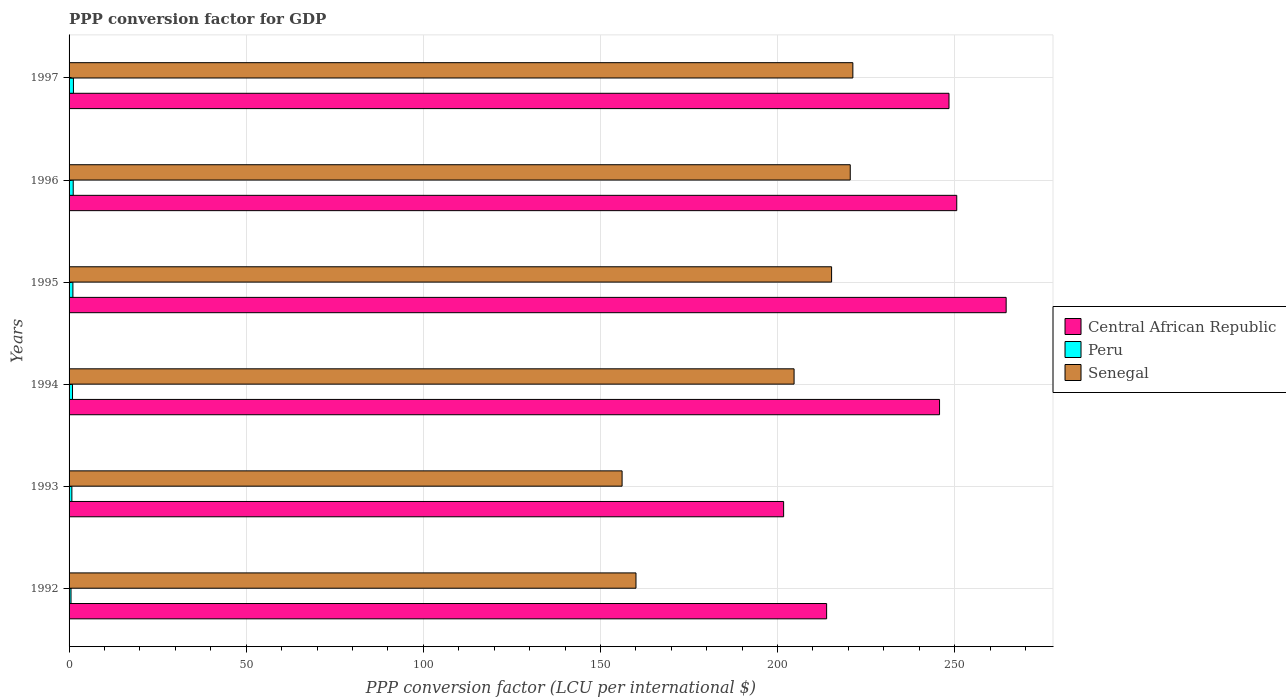How many groups of bars are there?
Provide a short and direct response. 6. How many bars are there on the 3rd tick from the top?
Provide a succinct answer. 3. How many bars are there on the 5th tick from the bottom?
Offer a terse response. 3. What is the PPP conversion factor for GDP in Peru in 1993?
Provide a succinct answer. 0.79. Across all years, what is the maximum PPP conversion factor for GDP in Peru?
Offer a very short reply. 1.23. Across all years, what is the minimum PPP conversion factor for GDP in Central African Republic?
Your answer should be compact. 201.72. In which year was the PPP conversion factor for GDP in Senegal minimum?
Offer a terse response. 1993. What is the total PPP conversion factor for GDP in Senegal in the graph?
Keep it short and to the point. 1177.87. What is the difference between the PPP conversion factor for GDP in Peru in 1996 and that in 1997?
Your answer should be very brief. -0.06. What is the difference between the PPP conversion factor for GDP in Peru in 1993 and the PPP conversion factor for GDP in Senegal in 1997?
Offer a terse response. -220.47. What is the average PPP conversion factor for GDP in Senegal per year?
Give a very brief answer. 196.31. In the year 1996, what is the difference between the PPP conversion factor for GDP in Senegal and PPP conversion factor for GDP in Central African Republic?
Your answer should be compact. -30.06. What is the ratio of the PPP conversion factor for GDP in Central African Republic in 1995 to that in 1996?
Provide a succinct answer. 1.06. Is the PPP conversion factor for GDP in Peru in 1994 less than that in 1995?
Give a very brief answer. Yes. What is the difference between the highest and the second highest PPP conversion factor for GDP in Senegal?
Offer a very short reply. 0.74. What is the difference between the highest and the lowest PPP conversion factor for GDP in Central African Republic?
Offer a very short reply. 62.82. In how many years, is the PPP conversion factor for GDP in Central African Republic greater than the average PPP conversion factor for GDP in Central African Republic taken over all years?
Ensure brevity in your answer.  4. What does the 3rd bar from the top in 1994 represents?
Your answer should be compact. Central African Republic. What does the 3rd bar from the bottom in 1993 represents?
Make the answer very short. Senegal. How many bars are there?
Keep it short and to the point. 18. What is the difference between two consecutive major ticks on the X-axis?
Your response must be concise. 50. Does the graph contain grids?
Provide a succinct answer. Yes. Where does the legend appear in the graph?
Provide a succinct answer. Center right. How many legend labels are there?
Your answer should be compact. 3. How are the legend labels stacked?
Provide a succinct answer. Vertical. What is the title of the graph?
Offer a very short reply. PPP conversion factor for GDP. What is the label or title of the X-axis?
Make the answer very short. PPP conversion factor (LCU per international $). What is the label or title of the Y-axis?
Your answer should be compact. Years. What is the PPP conversion factor (LCU per international $) in Central African Republic in 1992?
Offer a terse response. 213.86. What is the PPP conversion factor (LCU per international $) of Peru in 1992?
Ensure brevity in your answer.  0.55. What is the PPP conversion factor (LCU per international $) of Senegal in 1992?
Make the answer very short. 160.04. What is the PPP conversion factor (LCU per international $) in Central African Republic in 1993?
Your answer should be compact. 201.72. What is the PPP conversion factor (LCU per international $) of Peru in 1993?
Give a very brief answer. 0.79. What is the PPP conversion factor (LCU per international $) in Senegal in 1993?
Your response must be concise. 156.12. What is the PPP conversion factor (LCU per international $) of Central African Republic in 1994?
Offer a terse response. 245.73. What is the PPP conversion factor (LCU per international $) of Peru in 1994?
Your answer should be very brief. 0.97. What is the PPP conversion factor (LCU per international $) in Senegal in 1994?
Offer a terse response. 204.67. What is the PPP conversion factor (LCU per international $) in Central African Republic in 1995?
Provide a succinct answer. 264.54. What is the PPP conversion factor (LCU per international $) of Peru in 1995?
Your response must be concise. 1.08. What is the PPP conversion factor (LCU per international $) in Senegal in 1995?
Your answer should be very brief. 215.26. What is the PPP conversion factor (LCU per international $) of Central African Republic in 1996?
Offer a terse response. 250.59. What is the PPP conversion factor (LCU per international $) of Peru in 1996?
Make the answer very short. 1.17. What is the PPP conversion factor (LCU per international $) in Senegal in 1996?
Offer a terse response. 220.53. What is the PPP conversion factor (LCU per international $) of Central African Republic in 1997?
Your response must be concise. 248.4. What is the PPP conversion factor (LCU per international $) in Peru in 1997?
Give a very brief answer. 1.23. What is the PPP conversion factor (LCU per international $) of Senegal in 1997?
Make the answer very short. 221.26. Across all years, what is the maximum PPP conversion factor (LCU per international $) in Central African Republic?
Provide a short and direct response. 264.54. Across all years, what is the maximum PPP conversion factor (LCU per international $) in Peru?
Give a very brief answer. 1.23. Across all years, what is the maximum PPP conversion factor (LCU per international $) of Senegal?
Give a very brief answer. 221.26. Across all years, what is the minimum PPP conversion factor (LCU per international $) of Central African Republic?
Offer a very short reply. 201.72. Across all years, what is the minimum PPP conversion factor (LCU per international $) of Peru?
Ensure brevity in your answer.  0.55. Across all years, what is the minimum PPP conversion factor (LCU per international $) of Senegal?
Your response must be concise. 156.12. What is the total PPP conversion factor (LCU per international $) of Central African Republic in the graph?
Ensure brevity in your answer.  1424.84. What is the total PPP conversion factor (LCU per international $) in Peru in the graph?
Make the answer very short. 5.8. What is the total PPP conversion factor (LCU per international $) of Senegal in the graph?
Provide a short and direct response. 1177.87. What is the difference between the PPP conversion factor (LCU per international $) of Central African Republic in 1992 and that in 1993?
Offer a very short reply. 12.14. What is the difference between the PPP conversion factor (LCU per international $) in Peru in 1992 and that in 1993?
Give a very brief answer. -0.24. What is the difference between the PPP conversion factor (LCU per international $) of Senegal in 1992 and that in 1993?
Your answer should be very brief. 3.92. What is the difference between the PPP conversion factor (LCU per international $) in Central African Republic in 1992 and that in 1994?
Offer a terse response. -31.87. What is the difference between the PPP conversion factor (LCU per international $) in Peru in 1992 and that in 1994?
Offer a very short reply. -0.42. What is the difference between the PPP conversion factor (LCU per international $) in Senegal in 1992 and that in 1994?
Keep it short and to the point. -44.63. What is the difference between the PPP conversion factor (LCU per international $) of Central African Republic in 1992 and that in 1995?
Provide a short and direct response. -50.68. What is the difference between the PPP conversion factor (LCU per international $) of Peru in 1992 and that in 1995?
Make the answer very short. -0.53. What is the difference between the PPP conversion factor (LCU per international $) in Senegal in 1992 and that in 1995?
Give a very brief answer. -55.22. What is the difference between the PPP conversion factor (LCU per international $) of Central African Republic in 1992 and that in 1996?
Keep it short and to the point. -36.73. What is the difference between the PPP conversion factor (LCU per international $) in Peru in 1992 and that in 1996?
Your answer should be very brief. -0.62. What is the difference between the PPP conversion factor (LCU per international $) of Senegal in 1992 and that in 1996?
Provide a short and direct response. -60.49. What is the difference between the PPP conversion factor (LCU per international $) of Central African Republic in 1992 and that in 1997?
Offer a terse response. -34.54. What is the difference between the PPP conversion factor (LCU per international $) of Peru in 1992 and that in 1997?
Your answer should be very brief. -0.68. What is the difference between the PPP conversion factor (LCU per international $) of Senegal in 1992 and that in 1997?
Your answer should be compact. -61.22. What is the difference between the PPP conversion factor (LCU per international $) of Central African Republic in 1993 and that in 1994?
Give a very brief answer. -44.01. What is the difference between the PPP conversion factor (LCU per international $) in Peru in 1993 and that in 1994?
Provide a succinct answer. -0.18. What is the difference between the PPP conversion factor (LCU per international $) of Senegal in 1993 and that in 1994?
Keep it short and to the point. -48.55. What is the difference between the PPP conversion factor (LCU per international $) of Central African Republic in 1993 and that in 1995?
Keep it short and to the point. -62.82. What is the difference between the PPP conversion factor (LCU per international $) in Peru in 1993 and that in 1995?
Provide a succinct answer. -0.29. What is the difference between the PPP conversion factor (LCU per international $) of Senegal in 1993 and that in 1995?
Keep it short and to the point. -59.14. What is the difference between the PPP conversion factor (LCU per international $) of Central African Republic in 1993 and that in 1996?
Give a very brief answer. -48.87. What is the difference between the PPP conversion factor (LCU per international $) in Peru in 1993 and that in 1996?
Offer a very short reply. -0.38. What is the difference between the PPP conversion factor (LCU per international $) of Senegal in 1993 and that in 1996?
Keep it short and to the point. -64.41. What is the difference between the PPP conversion factor (LCU per international $) of Central African Republic in 1993 and that in 1997?
Provide a succinct answer. -46.68. What is the difference between the PPP conversion factor (LCU per international $) of Peru in 1993 and that in 1997?
Your answer should be compact. -0.44. What is the difference between the PPP conversion factor (LCU per international $) of Senegal in 1993 and that in 1997?
Offer a terse response. -65.15. What is the difference between the PPP conversion factor (LCU per international $) in Central African Republic in 1994 and that in 1995?
Your answer should be compact. -18.81. What is the difference between the PPP conversion factor (LCU per international $) in Peru in 1994 and that in 1995?
Ensure brevity in your answer.  -0.11. What is the difference between the PPP conversion factor (LCU per international $) of Senegal in 1994 and that in 1995?
Your answer should be compact. -10.59. What is the difference between the PPP conversion factor (LCU per international $) of Central African Republic in 1994 and that in 1996?
Ensure brevity in your answer.  -4.86. What is the difference between the PPP conversion factor (LCU per international $) in Peru in 1994 and that in 1996?
Make the answer very short. -0.2. What is the difference between the PPP conversion factor (LCU per international $) in Senegal in 1994 and that in 1996?
Provide a short and direct response. -15.86. What is the difference between the PPP conversion factor (LCU per international $) in Central African Republic in 1994 and that in 1997?
Give a very brief answer. -2.67. What is the difference between the PPP conversion factor (LCU per international $) in Peru in 1994 and that in 1997?
Keep it short and to the point. -0.26. What is the difference between the PPP conversion factor (LCU per international $) in Senegal in 1994 and that in 1997?
Give a very brief answer. -16.59. What is the difference between the PPP conversion factor (LCU per international $) of Central African Republic in 1995 and that in 1996?
Offer a terse response. 13.95. What is the difference between the PPP conversion factor (LCU per international $) of Peru in 1995 and that in 1996?
Your answer should be compact. -0.09. What is the difference between the PPP conversion factor (LCU per international $) in Senegal in 1995 and that in 1996?
Your response must be concise. -5.27. What is the difference between the PPP conversion factor (LCU per international $) in Central African Republic in 1995 and that in 1997?
Your answer should be very brief. 16.14. What is the difference between the PPP conversion factor (LCU per international $) of Peru in 1995 and that in 1997?
Offer a very short reply. -0.15. What is the difference between the PPP conversion factor (LCU per international $) in Senegal in 1995 and that in 1997?
Give a very brief answer. -6. What is the difference between the PPP conversion factor (LCU per international $) of Central African Republic in 1996 and that in 1997?
Offer a terse response. 2.19. What is the difference between the PPP conversion factor (LCU per international $) in Peru in 1996 and that in 1997?
Ensure brevity in your answer.  -0.06. What is the difference between the PPP conversion factor (LCU per international $) of Senegal in 1996 and that in 1997?
Your answer should be very brief. -0.74. What is the difference between the PPP conversion factor (LCU per international $) in Central African Republic in 1992 and the PPP conversion factor (LCU per international $) in Peru in 1993?
Give a very brief answer. 213.07. What is the difference between the PPP conversion factor (LCU per international $) in Central African Republic in 1992 and the PPP conversion factor (LCU per international $) in Senegal in 1993?
Offer a very short reply. 57.74. What is the difference between the PPP conversion factor (LCU per international $) in Peru in 1992 and the PPP conversion factor (LCU per international $) in Senegal in 1993?
Give a very brief answer. -155.57. What is the difference between the PPP conversion factor (LCU per international $) of Central African Republic in 1992 and the PPP conversion factor (LCU per international $) of Peru in 1994?
Provide a short and direct response. 212.89. What is the difference between the PPP conversion factor (LCU per international $) in Central African Republic in 1992 and the PPP conversion factor (LCU per international $) in Senegal in 1994?
Your response must be concise. 9.19. What is the difference between the PPP conversion factor (LCU per international $) in Peru in 1992 and the PPP conversion factor (LCU per international $) in Senegal in 1994?
Your answer should be compact. -204.12. What is the difference between the PPP conversion factor (LCU per international $) in Central African Republic in 1992 and the PPP conversion factor (LCU per international $) in Peru in 1995?
Keep it short and to the point. 212.77. What is the difference between the PPP conversion factor (LCU per international $) of Central African Republic in 1992 and the PPP conversion factor (LCU per international $) of Senegal in 1995?
Make the answer very short. -1.4. What is the difference between the PPP conversion factor (LCU per international $) in Peru in 1992 and the PPP conversion factor (LCU per international $) in Senegal in 1995?
Ensure brevity in your answer.  -214.71. What is the difference between the PPP conversion factor (LCU per international $) of Central African Republic in 1992 and the PPP conversion factor (LCU per international $) of Peru in 1996?
Offer a terse response. 212.69. What is the difference between the PPP conversion factor (LCU per international $) in Central African Republic in 1992 and the PPP conversion factor (LCU per international $) in Senegal in 1996?
Your answer should be compact. -6.67. What is the difference between the PPP conversion factor (LCU per international $) in Peru in 1992 and the PPP conversion factor (LCU per international $) in Senegal in 1996?
Provide a succinct answer. -219.98. What is the difference between the PPP conversion factor (LCU per international $) of Central African Republic in 1992 and the PPP conversion factor (LCU per international $) of Peru in 1997?
Your answer should be compact. 212.62. What is the difference between the PPP conversion factor (LCU per international $) in Central African Republic in 1992 and the PPP conversion factor (LCU per international $) in Senegal in 1997?
Offer a terse response. -7.4. What is the difference between the PPP conversion factor (LCU per international $) in Peru in 1992 and the PPP conversion factor (LCU per international $) in Senegal in 1997?
Your answer should be very brief. -220.71. What is the difference between the PPP conversion factor (LCU per international $) of Central African Republic in 1993 and the PPP conversion factor (LCU per international $) of Peru in 1994?
Keep it short and to the point. 200.75. What is the difference between the PPP conversion factor (LCU per international $) in Central African Republic in 1993 and the PPP conversion factor (LCU per international $) in Senegal in 1994?
Ensure brevity in your answer.  -2.95. What is the difference between the PPP conversion factor (LCU per international $) in Peru in 1993 and the PPP conversion factor (LCU per international $) in Senegal in 1994?
Offer a very short reply. -203.88. What is the difference between the PPP conversion factor (LCU per international $) in Central African Republic in 1993 and the PPP conversion factor (LCU per international $) in Peru in 1995?
Make the answer very short. 200.63. What is the difference between the PPP conversion factor (LCU per international $) in Central African Republic in 1993 and the PPP conversion factor (LCU per international $) in Senegal in 1995?
Your answer should be compact. -13.54. What is the difference between the PPP conversion factor (LCU per international $) in Peru in 1993 and the PPP conversion factor (LCU per international $) in Senegal in 1995?
Provide a succinct answer. -214.47. What is the difference between the PPP conversion factor (LCU per international $) of Central African Republic in 1993 and the PPP conversion factor (LCU per international $) of Peru in 1996?
Give a very brief answer. 200.55. What is the difference between the PPP conversion factor (LCU per international $) of Central African Republic in 1993 and the PPP conversion factor (LCU per international $) of Senegal in 1996?
Make the answer very short. -18.81. What is the difference between the PPP conversion factor (LCU per international $) of Peru in 1993 and the PPP conversion factor (LCU per international $) of Senegal in 1996?
Offer a terse response. -219.74. What is the difference between the PPP conversion factor (LCU per international $) in Central African Republic in 1993 and the PPP conversion factor (LCU per international $) in Peru in 1997?
Your answer should be very brief. 200.48. What is the difference between the PPP conversion factor (LCU per international $) in Central African Republic in 1993 and the PPP conversion factor (LCU per international $) in Senegal in 1997?
Give a very brief answer. -19.54. What is the difference between the PPP conversion factor (LCU per international $) of Peru in 1993 and the PPP conversion factor (LCU per international $) of Senegal in 1997?
Give a very brief answer. -220.47. What is the difference between the PPP conversion factor (LCU per international $) in Central African Republic in 1994 and the PPP conversion factor (LCU per international $) in Peru in 1995?
Make the answer very short. 244.65. What is the difference between the PPP conversion factor (LCU per international $) of Central African Republic in 1994 and the PPP conversion factor (LCU per international $) of Senegal in 1995?
Offer a very short reply. 30.47. What is the difference between the PPP conversion factor (LCU per international $) in Peru in 1994 and the PPP conversion factor (LCU per international $) in Senegal in 1995?
Provide a short and direct response. -214.29. What is the difference between the PPP conversion factor (LCU per international $) in Central African Republic in 1994 and the PPP conversion factor (LCU per international $) in Peru in 1996?
Provide a succinct answer. 244.56. What is the difference between the PPP conversion factor (LCU per international $) of Central African Republic in 1994 and the PPP conversion factor (LCU per international $) of Senegal in 1996?
Your answer should be compact. 25.21. What is the difference between the PPP conversion factor (LCU per international $) in Peru in 1994 and the PPP conversion factor (LCU per international $) in Senegal in 1996?
Your answer should be compact. -219.55. What is the difference between the PPP conversion factor (LCU per international $) of Central African Republic in 1994 and the PPP conversion factor (LCU per international $) of Peru in 1997?
Offer a terse response. 244.5. What is the difference between the PPP conversion factor (LCU per international $) in Central African Republic in 1994 and the PPP conversion factor (LCU per international $) in Senegal in 1997?
Ensure brevity in your answer.  24.47. What is the difference between the PPP conversion factor (LCU per international $) of Peru in 1994 and the PPP conversion factor (LCU per international $) of Senegal in 1997?
Ensure brevity in your answer.  -220.29. What is the difference between the PPP conversion factor (LCU per international $) of Central African Republic in 1995 and the PPP conversion factor (LCU per international $) of Peru in 1996?
Make the answer very short. 263.37. What is the difference between the PPP conversion factor (LCU per international $) of Central African Republic in 1995 and the PPP conversion factor (LCU per international $) of Senegal in 1996?
Your answer should be compact. 44.01. What is the difference between the PPP conversion factor (LCU per international $) in Peru in 1995 and the PPP conversion factor (LCU per international $) in Senegal in 1996?
Give a very brief answer. -219.44. What is the difference between the PPP conversion factor (LCU per international $) in Central African Republic in 1995 and the PPP conversion factor (LCU per international $) in Peru in 1997?
Make the answer very short. 263.3. What is the difference between the PPP conversion factor (LCU per international $) in Central African Republic in 1995 and the PPP conversion factor (LCU per international $) in Senegal in 1997?
Make the answer very short. 43.28. What is the difference between the PPP conversion factor (LCU per international $) in Peru in 1995 and the PPP conversion factor (LCU per international $) in Senegal in 1997?
Make the answer very short. -220.18. What is the difference between the PPP conversion factor (LCU per international $) in Central African Republic in 1996 and the PPP conversion factor (LCU per international $) in Peru in 1997?
Keep it short and to the point. 249.36. What is the difference between the PPP conversion factor (LCU per international $) of Central African Republic in 1996 and the PPP conversion factor (LCU per international $) of Senegal in 1997?
Ensure brevity in your answer.  29.33. What is the difference between the PPP conversion factor (LCU per international $) of Peru in 1996 and the PPP conversion factor (LCU per international $) of Senegal in 1997?
Ensure brevity in your answer.  -220.09. What is the average PPP conversion factor (LCU per international $) in Central African Republic per year?
Ensure brevity in your answer.  237.47. What is the average PPP conversion factor (LCU per international $) of Peru per year?
Ensure brevity in your answer.  0.97. What is the average PPP conversion factor (LCU per international $) in Senegal per year?
Give a very brief answer. 196.31. In the year 1992, what is the difference between the PPP conversion factor (LCU per international $) of Central African Republic and PPP conversion factor (LCU per international $) of Peru?
Your answer should be compact. 213.31. In the year 1992, what is the difference between the PPP conversion factor (LCU per international $) in Central African Republic and PPP conversion factor (LCU per international $) in Senegal?
Give a very brief answer. 53.82. In the year 1992, what is the difference between the PPP conversion factor (LCU per international $) of Peru and PPP conversion factor (LCU per international $) of Senegal?
Your answer should be compact. -159.49. In the year 1993, what is the difference between the PPP conversion factor (LCU per international $) of Central African Republic and PPP conversion factor (LCU per international $) of Peru?
Ensure brevity in your answer.  200.93. In the year 1993, what is the difference between the PPP conversion factor (LCU per international $) of Central African Republic and PPP conversion factor (LCU per international $) of Senegal?
Keep it short and to the point. 45.6. In the year 1993, what is the difference between the PPP conversion factor (LCU per international $) in Peru and PPP conversion factor (LCU per international $) in Senegal?
Make the answer very short. -155.32. In the year 1994, what is the difference between the PPP conversion factor (LCU per international $) in Central African Republic and PPP conversion factor (LCU per international $) in Peru?
Give a very brief answer. 244.76. In the year 1994, what is the difference between the PPP conversion factor (LCU per international $) in Central African Republic and PPP conversion factor (LCU per international $) in Senegal?
Give a very brief answer. 41.06. In the year 1994, what is the difference between the PPP conversion factor (LCU per international $) in Peru and PPP conversion factor (LCU per international $) in Senegal?
Ensure brevity in your answer.  -203.7. In the year 1995, what is the difference between the PPP conversion factor (LCU per international $) in Central African Republic and PPP conversion factor (LCU per international $) in Peru?
Give a very brief answer. 263.45. In the year 1995, what is the difference between the PPP conversion factor (LCU per international $) of Central African Republic and PPP conversion factor (LCU per international $) of Senegal?
Offer a very short reply. 49.28. In the year 1995, what is the difference between the PPP conversion factor (LCU per international $) in Peru and PPP conversion factor (LCU per international $) in Senegal?
Offer a very short reply. -214.18. In the year 1996, what is the difference between the PPP conversion factor (LCU per international $) of Central African Republic and PPP conversion factor (LCU per international $) of Peru?
Ensure brevity in your answer.  249.42. In the year 1996, what is the difference between the PPP conversion factor (LCU per international $) in Central African Republic and PPP conversion factor (LCU per international $) in Senegal?
Keep it short and to the point. 30.06. In the year 1996, what is the difference between the PPP conversion factor (LCU per international $) of Peru and PPP conversion factor (LCU per international $) of Senegal?
Ensure brevity in your answer.  -219.36. In the year 1997, what is the difference between the PPP conversion factor (LCU per international $) in Central African Republic and PPP conversion factor (LCU per international $) in Peru?
Make the answer very short. 247.17. In the year 1997, what is the difference between the PPP conversion factor (LCU per international $) in Central African Republic and PPP conversion factor (LCU per international $) in Senegal?
Give a very brief answer. 27.14. In the year 1997, what is the difference between the PPP conversion factor (LCU per international $) of Peru and PPP conversion factor (LCU per international $) of Senegal?
Provide a short and direct response. -220.03. What is the ratio of the PPP conversion factor (LCU per international $) of Central African Republic in 1992 to that in 1993?
Your response must be concise. 1.06. What is the ratio of the PPP conversion factor (LCU per international $) in Peru in 1992 to that in 1993?
Your response must be concise. 0.7. What is the ratio of the PPP conversion factor (LCU per international $) in Senegal in 1992 to that in 1993?
Ensure brevity in your answer.  1.03. What is the ratio of the PPP conversion factor (LCU per international $) in Central African Republic in 1992 to that in 1994?
Make the answer very short. 0.87. What is the ratio of the PPP conversion factor (LCU per international $) of Peru in 1992 to that in 1994?
Offer a very short reply. 0.57. What is the ratio of the PPP conversion factor (LCU per international $) of Senegal in 1992 to that in 1994?
Give a very brief answer. 0.78. What is the ratio of the PPP conversion factor (LCU per international $) in Central African Republic in 1992 to that in 1995?
Provide a short and direct response. 0.81. What is the ratio of the PPP conversion factor (LCU per international $) of Peru in 1992 to that in 1995?
Your response must be concise. 0.51. What is the ratio of the PPP conversion factor (LCU per international $) of Senegal in 1992 to that in 1995?
Offer a terse response. 0.74. What is the ratio of the PPP conversion factor (LCU per international $) in Central African Republic in 1992 to that in 1996?
Offer a very short reply. 0.85. What is the ratio of the PPP conversion factor (LCU per international $) of Peru in 1992 to that in 1996?
Provide a succinct answer. 0.47. What is the ratio of the PPP conversion factor (LCU per international $) in Senegal in 1992 to that in 1996?
Offer a terse response. 0.73. What is the ratio of the PPP conversion factor (LCU per international $) of Central African Republic in 1992 to that in 1997?
Your answer should be very brief. 0.86. What is the ratio of the PPP conversion factor (LCU per international $) of Peru in 1992 to that in 1997?
Provide a short and direct response. 0.45. What is the ratio of the PPP conversion factor (LCU per international $) of Senegal in 1992 to that in 1997?
Your answer should be compact. 0.72. What is the ratio of the PPP conversion factor (LCU per international $) of Central African Republic in 1993 to that in 1994?
Offer a terse response. 0.82. What is the ratio of the PPP conversion factor (LCU per international $) in Peru in 1993 to that in 1994?
Ensure brevity in your answer.  0.81. What is the ratio of the PPP conversion factor (LCU per international $) of Senegal in 1993 to that in 1994?
Provide a short and direct response. 0.76. What is the ratio of the PPP conversion factor (LCU per international $) in Central African Republic in 1993 to that in 1995?
Offer a terse response. 0.76. What is the ratio of the PPP conversion factor (LCU per international $) in Peru in 1993 to that in 1995?
Ensure brevity in your answer.  0.73. What is the ratio of the PPP conversion factor (LCU per international $) in Senegal in 1993 to that in 1995?
Give a very brief answer. 0.73. What is the ratio of the PPP conversion factor (LCU per international $) in Central African Republic in 1993 to that in 1996?
Your answer should be compact. 0.81. What is the ratio of the PPP conversion factor (LCU per international $) in Peru in 1993 to that in 1996?
Provide a succinct answer. 0.68. What is the ratio of the PPP conversion factor (LCU per international $) of Senegal in 1993 to that in 1996?
Keep it short and to the point. 0.71. What is the ratio of the PPP conversion factor (LCU per international $) of Central African Republic in 1993 to that in 1997?
Make the answer very short. 0.81. What is the ratio of the PPP conversion factor (LCU per international $) in Peru in 1993 to that in 1997?
Keep it short and to the point. 0.64. What is the ratio of the PPP conversion factor (LCU per international $) in Senegal in 1993 to that in 1997?
Your answer should be compact. 0.71. What is the ratio of the PPP conversion factor (LCU per international $) of Central African Republic in 1994 to that in 1995?
Give a very brief answer. 0.93. What is the ratio of the PPP conversion factor (LCU per international $) of Peru in 1994 to that in 1995?
Provide a short and direct response. 0.9. What is the ratio of the PPP conversion factor (LCU per international $) in Senegal in 1994 to that in 1995?
Your response must be concise. 0.95. What is the ratio of the PPP conversion factor (LCU per international $) in Central African Republic in 1994 to that in 1996?
Your answer should be compact. 0.98. What is the ratio of the PPP conversion factor (LCU per international $) in Peru in 1994 to that in 1996?
Keep it short and to the point. 0.83. What is the ratio of the PPP conversion factor (LCU per international $) in Senegal in 1994 to that in 1996?
Ensure brevity in your answer.  0.93. What is the ratio of the PPP conversion factor (LCU per international $) of Central African Republic in 1994 to that in 1997?
Provide a short and direct response. 0.99. What is the ratio of the PPP conversion factor (LCU per international $) in Peru in 1994 to that in 1997?
Ensure brevity in your answer.  0.79. What is the ratio of the PPP conversion factor (LCU per international $) in Senegal in 1994 to that in 1997?
Ensure brevity in your answer.  0.93. What is the ratio of the PPP conversion factor (LCU per international $) of Central African Republic in 1995 to that in 1996?
Ensure brevity in your answer.  1.06. What is the ratio of the PPP conversion factor (LCU per international $) in Peru in 1995 to that in 1996?
Provide a short and direct response. 0.93. What is the ratio of the PPP conversion factor (LCU per international $) of Senegal in 1995 to that in 1996?
Offer a very short reply. 0.98. What is the ratio of the PPP conversion factor (LCU per international $) in Central African Republic in 1995 to that in 1997?
Your answer should be compact. 1.06. What is the ratio of the PPP conversion factor (LCU per international $) of Peru in 1995 to that in 1997?
Make the answer very short. 0.88. What is the ratio of the PPP conversion factor (LCU per international $) in Senegal in 1995 to that in 1997?
Ensure brevity in your answer.  0.97. What is the ratio of the PPP conversion factor (LCU per international $) of Central African Republic in 1996 to that in 1997?
Ensure brevity in your answer.  1.01. What is the ratio of the PPP conversion factor (LCU per international $) in Peru in 1996 to that in 1997?
Your answer should be very brief. 0.95. What is the ratio of the PPP conversion factor (LCU per international $) in Senegal in 1996 to that in 1997?
Your answer should be compact. 1. What is the difference between the highest and the second highest PPP conversion factor (LCU per international $) of Central African Republic?
Ensure brevity in your answer.  13.95. What is the difference between the highest and the second highest PPP conversion factor (LCU per international $) of Peru?
Your answer should be compact. 0.06. What is the difference between the highest and the second highest PPP conversion factor (LCU per international $) in Senegal?
Your answer should be compact. 0.74. What is the difference between the highest and the lowest PPP conversion factor (LCU per international $) of Central African Republic?
Make the answer very short. 62.82. What is the difference between the highest and the lowest PPP conversion factor (LCU per international $) in Peru?
Keep it short and to the point. 0.68. What is the difference between the highest and the lowest PPP conversion factor (LCU per international $) of Senegal?
Provide a short and direct response. 65.15. 